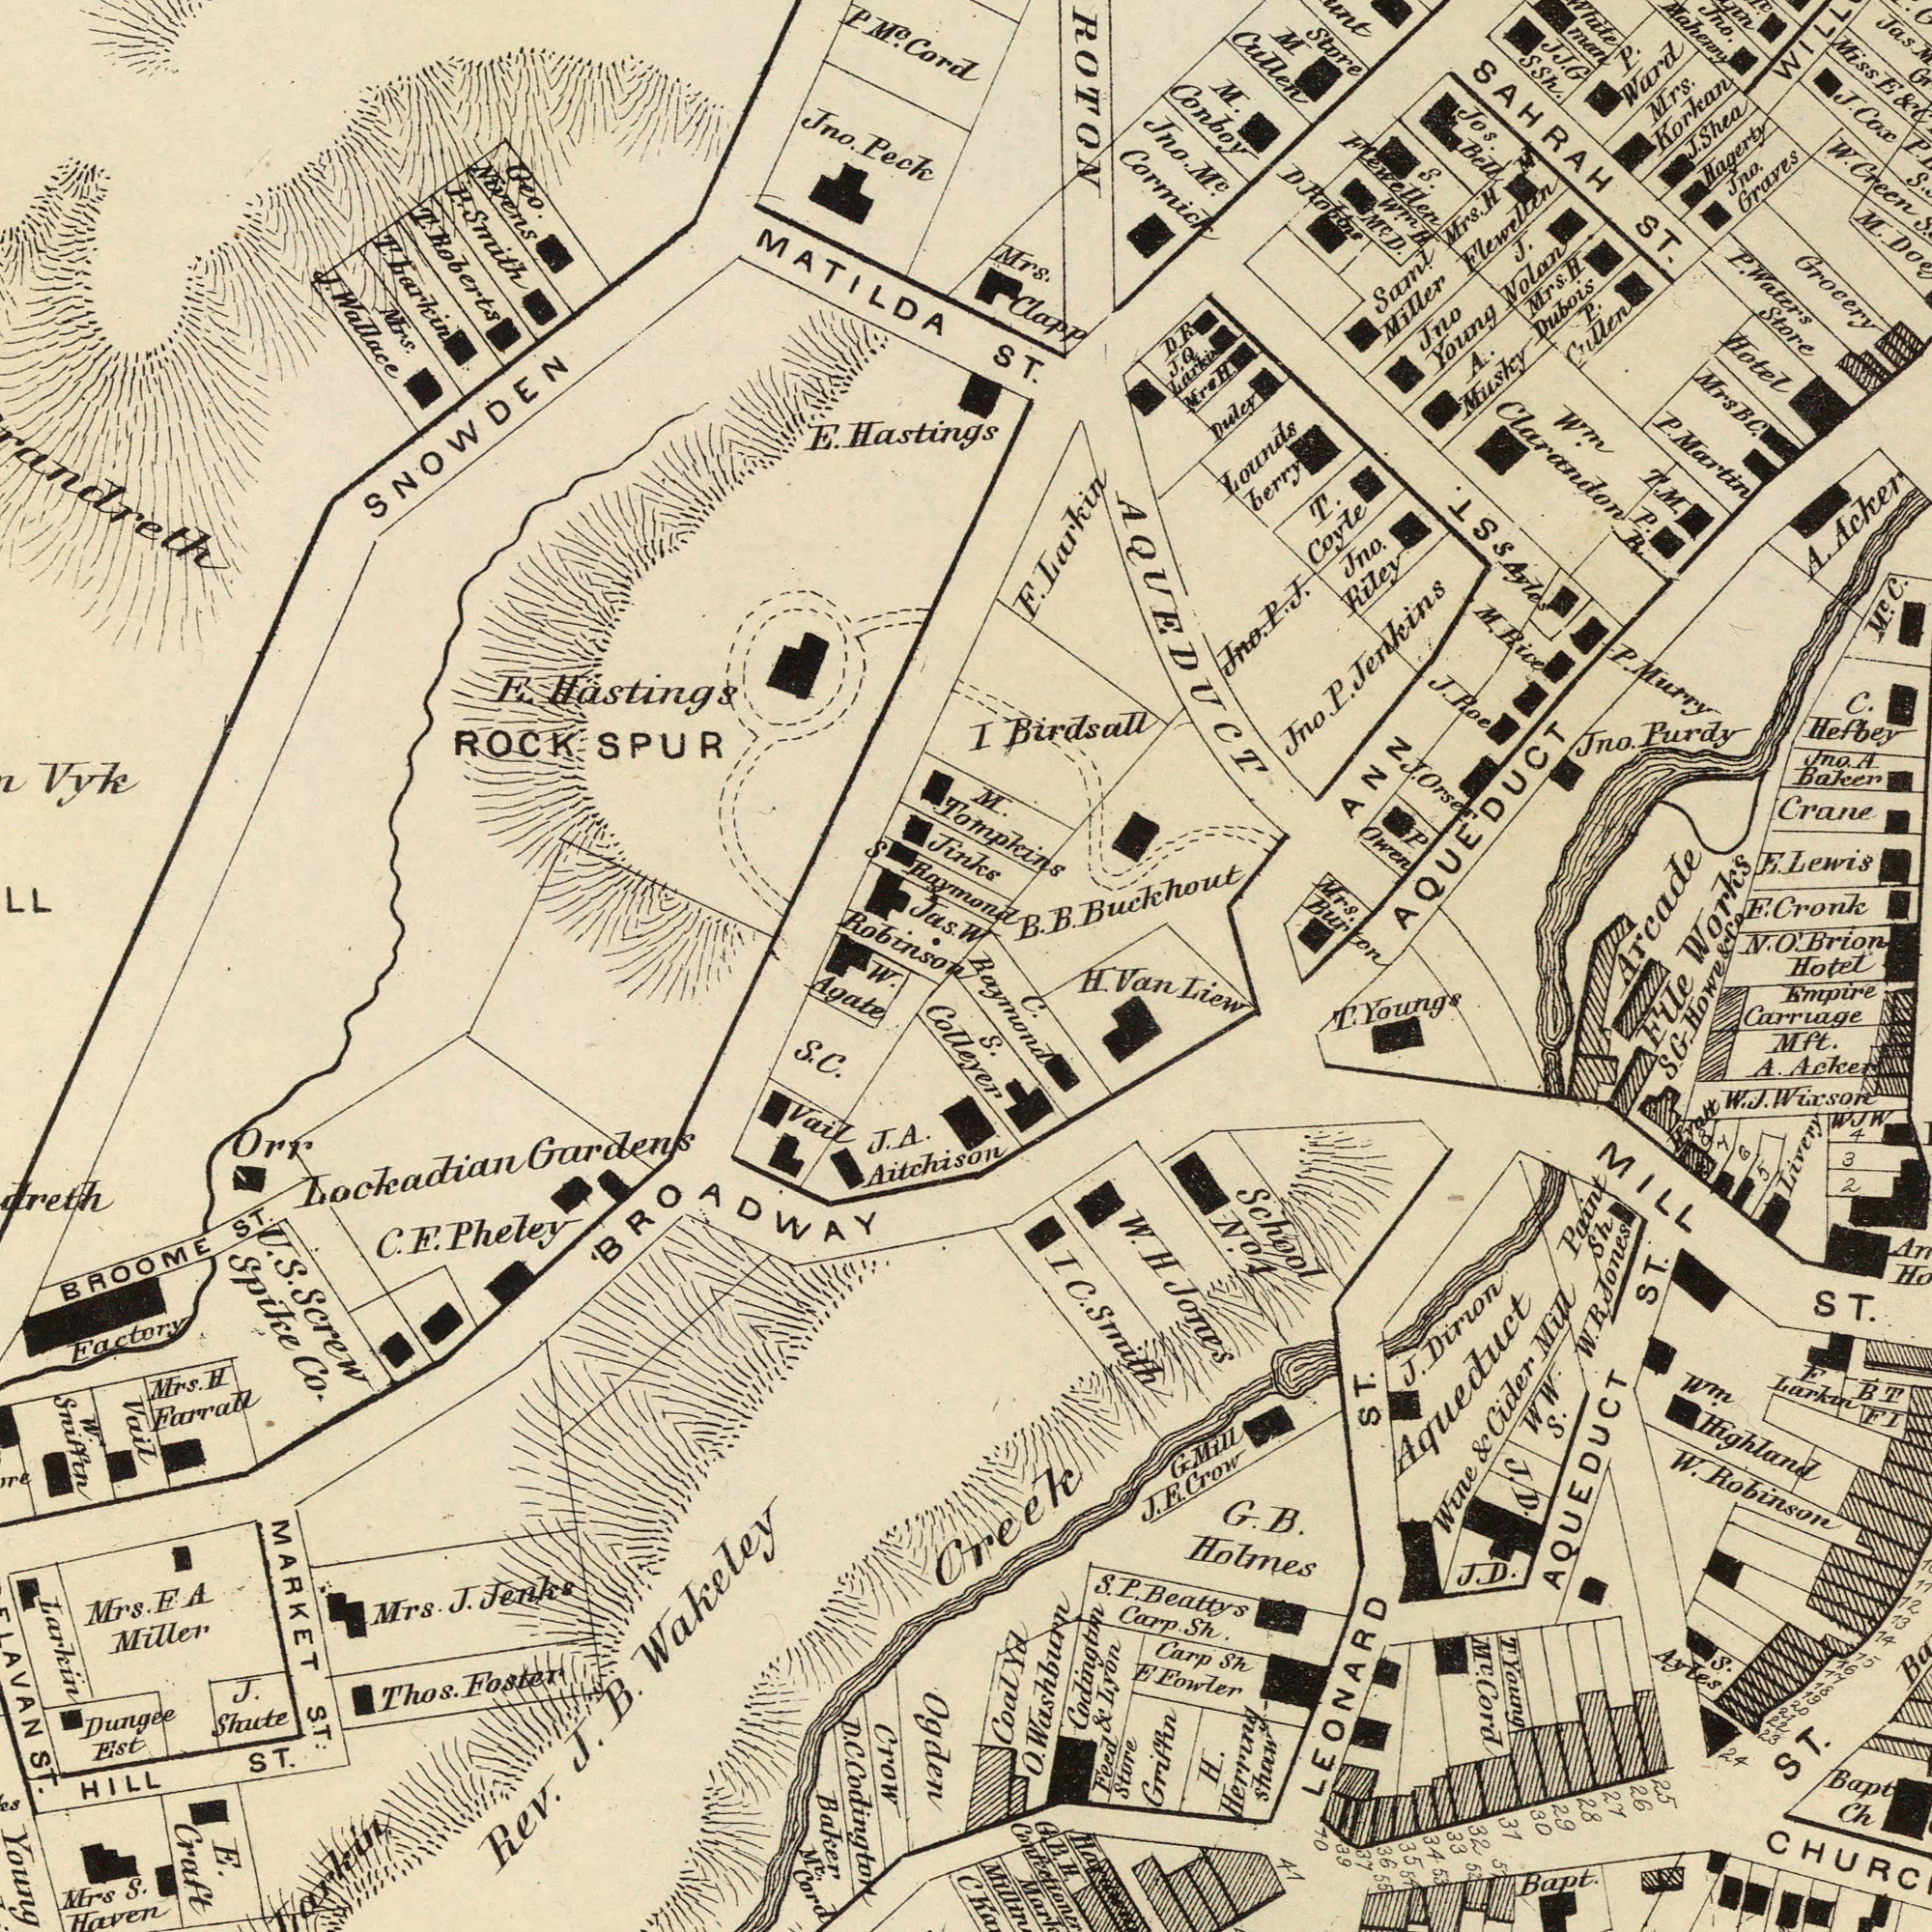What text appears in the top-left area of the image? E. Hastings E. Hastings Geo. Nivens Jno. Peck Mrs. J. Wallace ROCK SPUR S Raymond Jas. Robinson MATILDA SNOWDEN R. Smith P M<sup>c</sup>. Cord T. Roberts T. barkin Vyk Jinks What text is shown in the bottom-left quadrant? Rev. J. B. Wakeley Ogden U. S. Screw Spike Co. Young HILL ST. Lockadian Gardens E. Craft W. Agate Mrs F. A Miller Baker BROOME ST. Thos. Foster J. A. Aitchison Vail Orr Mrs S. Haven Mrs. J. Jenks Larkin Dungee Est Vail Mrs. H Farrall ST. J. Shute Factory C. F. Pheley MARKET ST. Crow W. Sniffin M<sup>c</sup>. BROADWAY Colleyer S. C. D. C. Codington Cord What text appears in the top-right area of the image? W ST. AQUEDUCT Crane SAHRAH ST. F. Cronk B. B. Buckhout F. Larkin Jno. Purdy Jno. M<sup>c</sup>. Cormick Mrs. Clapp Mrs. Korkan Store M Cullen P. Waters Store I Birdsall M. Conboy Jna. Graves Jno. A Baken Hotel Arcade Works A. Acker Lounds berry Jos. Bell M<sup>c</sup>. C. T. M. P. R T. Coyle P. Ward J. Roe Saml Miller J. Nolan Grocery Hagerty N. O. Brion Hotel F. Lewis Jno. P. Jenkins Jno. Riley AQUEDUCT M. C. Hefbey W<sup>m</sup> Clarandon Duley P. Cullen JJ. G Ssh. Mrs BC. P. Martin Jno Young M. Tompkins Mrs. H M Flewellen Miss E & Jas. Jno. P. J. M. Rive P Owen man Mrs. Burton P. Murry J. Shea J. Cox P. S. W. Green S. Flewellen Win H M<sup>c</sup>. D. Mrs. H Dubois D. Robons Ayles s ST. Mrs. H. D. R. J. Q. Larkin ANN J. Orser & Co A. Musky Jno. Mahenny What text is visible in the lower-right corner? File Mft. A. Acker W. Robinson Empire Carruage MILL ST. G. B. Holmes Feed Store Griffin LEONARD ST. Creek S. P. Beattys Carp. Sh. Bapt Ch Carp Sh E Fowler H. Herrung Shaw Bapt BT J. Dirlon Aqueduct Wine & Cider Mill W W. S. AQUEDUCT ST. Codington & Lyon F Larkin H. Van Liew School No.1 FI S. Ayles C. Baymond W. H Jones W. J. Wixson O. Washburn M<sup>c</sup>. Cord T Young WJW Livery Wm. Highland Paint Sh W. R. Jones T. Youngs S. ST. I C. Smith S. G. Howe 2 3 4 ###t 8 7 6 5 J. D. J. D. G. Mill J. E. Crow 12 13 14 15 16 17 18 19 20 21 22 23 24 25 26 27 28 29 30 31 32 33 34 35 36 37 39 40 41 51 52 53 54 55 C G. B. H. Coal Yd 